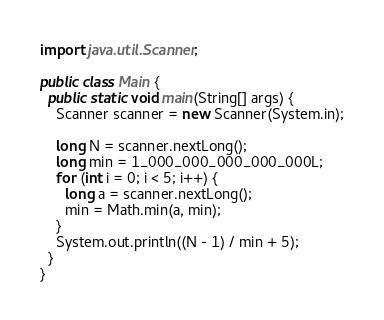Convert code to text. <code><loc_0><loc_0><loc_500><loc_500><_Java_>import java.util.Scanner;

public class Main {
  public static void main(String[] args) {
    Scanner scanner = new Scanner(System.in);

    long N = scanner.nextLong();
    long min = 1_000_000_000_000_000L;
    for (int i = 0; i < 5; i++) {
      long a = scanner.nextLong();
      min = Math.min(a, min);
    }
    System.out.println((N - 1) / min + 5);
  }
}
</code> 